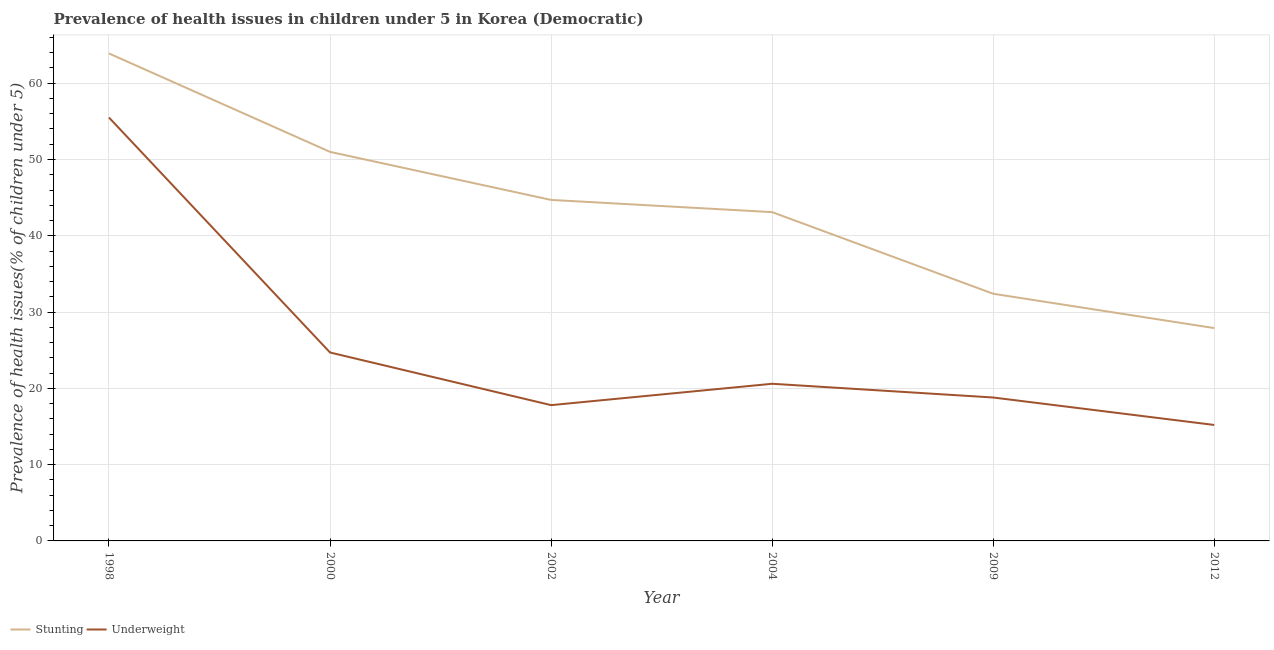Is the number of lines equal to the number of legend labels?
Your answer should be very brief. Yes. What is the percentage of underweight children in 1998?
Offer a very short reply. 55.5. Across all years, what is the maximum percentage of underweight children?
Your answer should be compact. 55.5. Across all years, what is the minimum percentage of stunted children?
Give a very brief answer. 27.9. In which year was the percentage of underweight children maximum?
Ensure brevity in your answer.  1998. In which year was the percentage of underweight children minimum?
Make the answer very short. 2012. What is the total percentage of underweight children in the graph?
Ensure brevity in your answer.  152.6. What is the difference between the percentage of stunted children in 1998 and that in 2009?
Keep it short and to the point. 31.5. What is the difference between the percentage of stunted children in 2009 and the percentage of underweight children in 2002?
Ensure brevity in your answer.  14.6. What is the average percentage of stunted children per year?
Provide a short and direct response. 43.83. In the year 1998, what is the difference between the percentage of underweight children and percentage of stunted children?
Provide a short and direct response. -8.4. In how many years, is the percentage of underweight children greater than 2 %?
Provide a short and direct response. 6. What is the ratio of the percentage of stunted children in 1998 to that in 2000?
Offer a terse response. 1.25. Is the difference between the percentage of underweight children in 1998 and 2009 greater than the difference between the percentage of stunted children in 1998 and 2009?
Ensure brevity in your answer.  Yes. What is the difference between the highest and the second highest percentage of stunted children?
Your answer should be compact. 12.9. What is the difference between the highest and the lowest percentage of stunted children?
Provide a succinct answer. 36. Is the sum of the percentage of stunted children in 1998 and 2012 greater than the maximum percentage of underweight children across all years?
Offer a very short reply. Yes. Is the percentage of underweight children strictly greater than the percentage of stunted children over the years?
Give a very brief answer. No. Is the percentage of stunted children strictly less than the percentage of underweight children over the years?
Offer a terse response. No. How many lines are there?
Ensure brevity in your answer.  2. Does the graph contain any zero values?
Your answer should be very brief. No. Where does the legend appear in the graph?
Keep it short and to the point. Bottom left. How are the legend labels stacked?
Provide a short and direct response. Horizontal. What is the title of the graph?
Keep it short and to the point. Prevalence of health issues in children under 5 in Korea (Democratic). What is the label or title of the X-axis?
Your answer should be compact. Year. What is the label or title of the Y-axis?
Provide a succinct answer. Prevalence of health issues(% of children under 5). What is the Prevalence of health issues(% of children under 5) in Stunting in 1998?
Provide a short and direct response. 63.9. What is the Prevalence of health issues(% of children under 5) of Underweight in 1998?
Your answer should be very brief. 55.5. What is the Prevalence of health issues(% of children under 5) of Underweight in 2000?
Your answer should be very brief. 24.7. What is the Prevalence of health issues(% of children under 5) of Stunting in 2002?
Offer a very short reply. 44.7. What is the Prevalence of health issues(% of children under 5) of Underweight in 2002?
Your answer should be very brief. 17.8. What is the Prevalence of health issues(% of children under 5) of Stunting in 2004?
Your response must be concise. 43.1. What is the Prevalence of health issues(% of children under 5) of Underweight in 2004?
Make the answer very short. 20.6. What is the Prevalence of health issues(% of children under 5) of Stunting in 2009?
Keep it short and to the point. 32.4. What is the Prevalence of health issues(% of children under 5) of Underweight in 2009?
Your answer should be very brief. 18.8. What is the Prevalence of health issues(% of children under 5) in Stunting in 2012?
Make the answer very short. 27.9. What is the Prevalence of health issues(% of children under 5) in Underweight in 2012?
Offer a terse response. 15.2. Across all years, what is the maximum Prevalence of health issues(% of children under 5) in Stunting?
Give a very brief answer. 63.9. Across all years, what is the maximum Prevalence of health issues(% of children under 5) of Underweight?
Your answer should be compact. 55.5. Across all years, what is the minimum Prevalence of health issues(% of children under 5) of Stunting?
Your answer should be very brief. 27.9. Across all years, what is the minimum Prevalence of health issues(% of children under 5) in Underweight?
Your answer should be compact. 15.2. What is the total Prevalence of health issues(% of children under 5) of Stunting in the graph?
Make the answer very short. 263. What is the total Prevalence of health issues(% of children under 5) of Underweight in the graph?
Keep it short and to the point. 152.6. What is the difference between the Prevalence of health issues(% of children under 5) of Underweight in 1998 and that in 2000?
Give a very brief answer. 30.8. What is the difference between the Prevalence of health issues(% of children under 5) in Stunting in 1998 and that in 2002?
Give a very brief answer. 19.2. What is the difference between the Prevalence of health issues(% of children under 5) in Underweight in 1998 and that in 2002?
Your answer should be very brief. 37.7. What is the difference between the Prevalence of health issues(% of children under 5) in Stunting in 1998 and that in 2004?
Provide a succinct answer. 20.8. What is the difference between the Prevalence of health issues(% of children under 5) in Underweight in 1998 and that in 2004?
Keep it short and to the point. 34.9. What is the difference between the Prevalence of health issues(% of children under 5) of Stunting in 1998 and that in 2009?
Make the answer very short. 31.5. What is the difference between the Prevalence of health issues(% of children under 5) of Underweight in 1998 and that in 2009?
Keep it short and to the point. 36.7. What is the difference between the Prevalence of health issues(% of children under 5) in Underweight in 1998 and that in 2012?
Ensure brevity in your answer.  40.3. What is the difference between the Prevalence of health issues(% of children under 5) of Stunting in 2000 and that in 2004?
Ensure brevity in your answer.  7.9. What is the difference between the Prevalence of health issues(% of children under 5) in Underweight in 2000 and that in 2009?
Your answer should be very brief. 5.9. What is the difference between the Prevalence of health issues(% of children under 5) of Stunting in 2000 and that in 2012?
Your answer should be very brief. 23.1. What is the difference between the Prevalence of health issues(% of children under 5) in Stunting in 2002 and that in 2009?
Your answer should be compact. 12.3. What is the difference between the Prevalence of health issues(% of children under 5) in Stunting in 2004 and that in 2012?
Your response must be concise. 15.2. What is the difference between the Prevalence of health issues(% of children under 5) in Underweight in 2009 and that in 2012?
Provide a succinct answer. 3.6. What is the difference between the Prevalence of health issues(% of children under 5) of Stunting in 1998 and the Prevalence of health issues(% of children under 5) of Underweight in 2000?
Provide a short and direct response. 39.2. What is the difference between the Prevalence of health issues(% of children under 5) of Stunting in 1998 and the Prevalence of health issues(% of children under 5) of Underweight in 2002?
Ensure brevity in your answer.  46.1. What is the difference between the Prevalence of health issues(% of children under 5) in Stunting in 1998 and the Prevalence of health issues(% of children under 5) in Underweight in 2004?
Your answer should be very brief. 43.3. What is the difference between the Prevalence of health issues(% of children under 5) in Stunting in 1998 and the Prevalence of health issues(% of children under 5) in Underweight in 2009?
Give a very brief answer. 45.1. What is the difference between the Prevalence of health issues(% of children under 5) of Stunting in 1998 and the Prevalence of health issues(% of children under 5) of Underweight in 2012?
Ensure brevity in your answer.  48.7. What is the difference between the Prevalence of health issues(% of children under 5) of Stunting in 2000 and the Prevalence of health issues(% of children under 5) of Underweight in 2002?
Keep it short and to the point. 33.2. What is the difference between the Prevalence of health issues(% of children under 5) in Stunting in 2000 and the Prevalence of health issues(% of children under 5) in Underweight in 2004?
Offer a very short reply. 30.4. What is the difference between the Prevalence of health issues(% of children under 5) of Stunting in 2000 and the Prevalence of health issues(% of children under 5) of Underweight in 2009?
Keep it short and to the point. 32.2. What is the difference between the Prevalence of health issues(% of children under 5) of Stunting in 2000 and the Prevalence of health issues(% of children under 5) of Underweight in 2012?
Ensure brevity in your answer.  35.8. What is the difference between the Prevalence of health issues(% of children under 5) of Stunting in 2002 and the Prevalence of health issues(% of children under 5) of Underweight in 2004?
Your answer should be very brief. 24.1. What is the difference between the Prevalence of health issues(% of children under 5) of Stunting in 2002 and the Prevalence of health issues(% of children under 5) of Underweight in 2009?
Provide a succinct answer. 25.9. What is the difference between the Prevalence of health issues(% of children under 5) of Stunting in 2002 and the Prevalence of health issues(% of children under 5) of Underweight in 2012?
Ensure brevity in your answer.  29.5. What is the difference between the Prevalence of health issues(% of children under 5) of Stunting in 2004 and the Prevalence of health issues(% of children under 5) of Underweight in 2009?
Offer a terse response. 24.3. What is the difference between the Prevalence of health issues(% of children under 5) of Stunting in 2004 and the Prevalence of health issues(% of children under 5) of Underweight in 2012?
Give a very brief answer. 27.9. What is the difference between the Prevalence of health issues(% of children under 5) of Stunting in 2009 and the Prevalence of health issues(% of children under 5) of Underweight in 2012?
Your answer should be compact. 17.2. What is the average Prevalence of health issues(% of children under 5) in Stunting per year?
Your response must be concise. 43.83. What is the average Prevalence of health issues(% of children under 5) of Underweight per year?
Provide a short and direct response. 25.43. In the year 1998, what is the difference between the Prevalence of health issues(% of children under 5) of Stunting and Prevalence of health issues(% of children under 5) of Underweight?
Give a very brief answer. 8.4. In the year 2000, what is the difference between the Prevalence of health issues(% of children under 5) in Stunting and Prevalence of health issues(% of children under 5) in Underweight?
Offer a terse response. 26.3. In the year 2002, what is the difference between the Prevalence of health issues(% of children under 5) in Stunting and Prevalence of health issues(% of children under 5) in Underweight?
Make the answer very short. 26.9. In the year 2012, what is the difference between the Prevalence of health issues(% of children under 5) of Stunting and Prevalence of health issues(% of children under 5) of Underweight?
Your answer should be very brief. 12.7. What is the ratio of the Prevalence of health issues(% of children under 5) in Stunting in 1998 to that in 2000?
Provide a short and direct response. 1.25. What is the ratio of the Prevalence of health issues(% of children under 5) of Underweight in 1998 to that in 2000?
Your response must be concise. 2.25. What is the ratio of the Prevalence of health issues(% of children under 5) of Stunting in 1998 to that in 2002?
Offer a very short reply. 1.43. What is the ratio of the Prevalence of health issues(% of children under 5) in Underweight in 1998 to that in 2002?
Offer a terse response. 3.12. What is the ratio of the Prevalence of health issues(% of children under 5) of Stunting in 1998 to that in 2004?
Your answer should be very brief. 1.48. What is the ratio of the Prevalence of health issues(% of children under 5) in Underweight in 1998 to that in 2004?
Ensure brevity in your answer.  2.69. What is the ratio of the Prevalence of health issues(% of children under 5) in Stunting in 1998 to that in 2009?
Offer a very short reply. 1.97. What is the ratio of the Prevalence of health issues(% of children under 5) in Underweight in 1998 to that in 2009?
Ensure brevity in your answer.  2.95. What is the ratio of the Prevalence of health issues(% of children under 5) in Stunting in 1998 to that in 2012?
Provide a succinct answer. 2.29. What is the ratio of the Prevalence of health issues(% of children under 5) in Underweight in 1998 to that in 2012?
Give a very brief answer. 3.65. What is the ratio of the Prevalence of health issues(% of children under 5) of Stunting in 2000 to that in 2002?
Ensure brevity in your answer.  1.14. What is the ratio of the Prevalence of health issues(% of children under 5) of Underweight in 2000 to that in 2002?
Provide a short and direct response. 1.39. What is the ratio of the Prevalence of health issues(% of children under 5) in Stunting in 2000 to that in 2004?
Provide a short and direct response. 1.18. What is the ratio of the Prevalence of health issues(% of children under 5) in Underweight in 2000 to that in 2004?
Your answer should be compact. 1.2. What is the ratio of the Prevalence of health issues(% of children under 5) of Stunting in 2000 to that in 2009?
Provide a succinct answer. 1.57. What is the ratio of the Prevalence of health issues(% of children under 5) in Underweight in 2000 to that in 2009?
Offer a terse response. 1.31. What is the ratio of the Prevalence of health issues(% of children under 5) of Stunting in 2000 to that in 2012?
Your response must be concise. 1.83. What is the ratio of the Prevalence of health issues(% of children under 5) in Underweight in 2000 to that in 2012?
Make the answer very short. 1.62. What is the ratio of the Prevalence of health issues(% of children under 5) in Stunting in 2002 to that in 2004?
Provide a succinct answer. 1.04. What is the ratio of the Prevalence of health issues(% of children under 5) in Underweight in 2002 to that in 2004?
Make the answer very short. 0.86. What is the ratio of the Prevalence of health issues(% of children under 5) in Stunting in 2002 to that in 2009?
Provide a short and direct response. 1.38. What is the ratio of the Prevalence of health issues(% of children under 5) of Underweight in 2002 to that in 2009?
Provide a succinct answer. 0.95. What is the ratio of the Prevalence of health issues(% of children under 5) of Stunting in 2002 to that in 2012?
Offer a terse response. 1.6. What is the ratio of the Prevalence of health issues(% of children under 5) of Underweight in 2002 to that in 2012?
Provide a succinct answer. 1.17. What is the ratio of the Prevalence of health issues(% of children under 5) of Stunting in 2004 to that in 2009?
Make the answer very short. 1.33. What is the ratio of the Prevalence of health issues(% of children under 5) in Underweight in 2004 to that in 2009?
Provide a succinct answer. 1.1. What is the ratio of the Prevalence of health issues(% of children under 5) of Stunting in 2004 to that in 2012?
Offer a very short reply. 1.54. What is the ratio of the Prevalence of health issues(% of children under 5) of Underweight in 2004 to that in 2012?
Provide a short and direct response. 1.36. What is the ratio of the Prevalence of health issues(% of children under 5) of Stunting in 2009 to that in 2012?
Provide a short and direct response. 1.16. What is the ratio of the Prevalence of health issues(% of children under 5) of Underweight in 2009 to that in 2012?
Provide a succinct answer. 1.24. What is the difference between the highest and the second highest Prevalence of health issues(% of children under 5) of Underweight?
Keep it short and to the point. 30.8. What is the difference between the highest and the lowest Prevalence of health issues(% of children under 5) of Underweight?
Ensure brevity in your answer.  40.3. 